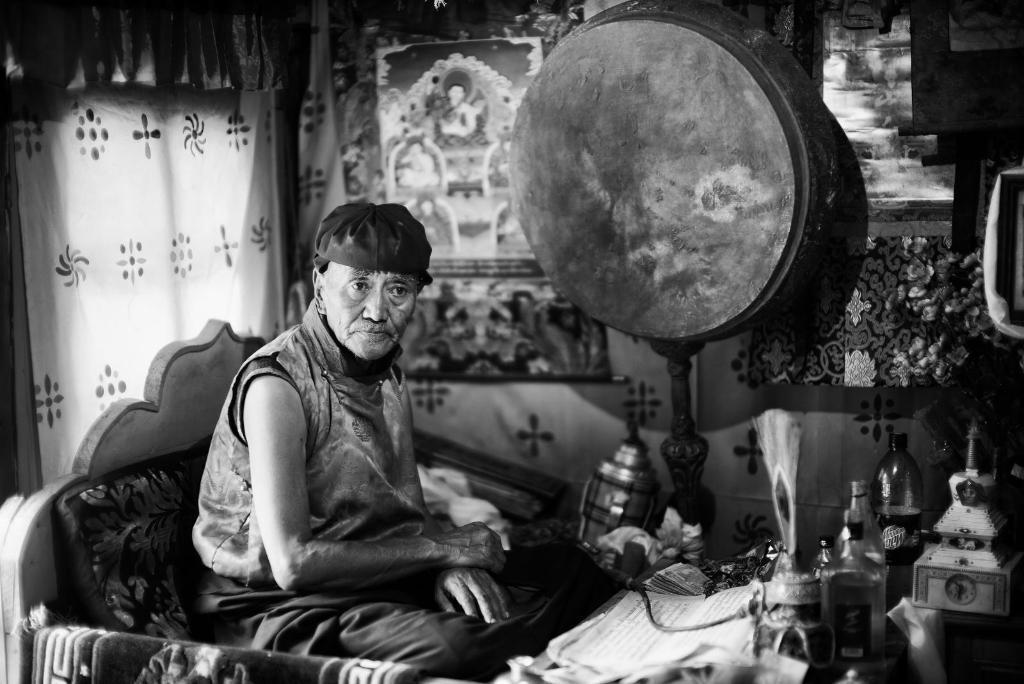Can you describe this image briefly? In this image there is a person sitting on the sofa, there are objects on the surface, there is an object truncated towards the right of the image, there is a curtain, there is a photo frame, there are objects on the ground, there is a cloth. 